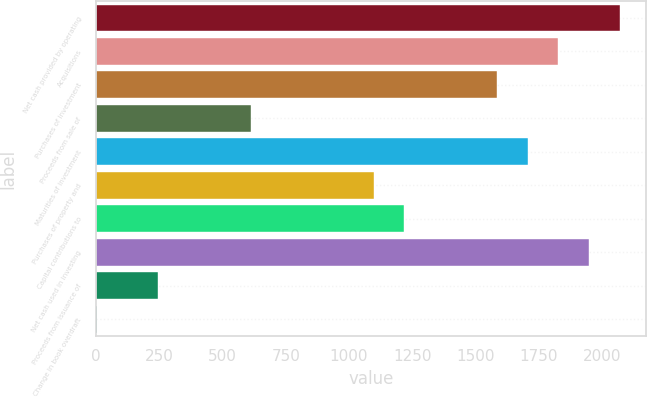Convert chart to OTSL. <chart><loc_0><loc_0><loc_500><loc_500><bar_chart><fcel>Net cash provided by operating<fcel>Acquisitions<fcel>Purchases of investment<fcel>Proceeds from sale of<fcel>Maturities of investment<fcel>Purchases of property and<fcel>Capital contributions to<fcel>Net cash used in investing<fcel>Proceeds from issuance of<fcel>Change in book overdraft<nl><fcel>2070.9<fcel>1827.5<fcel>1584.1<fcel>610.5<fcel>1705.8<fcel>1097.3<fcel>1219<fcel>1949.2<fcel>245.4<fcel>2<nl></chart> 